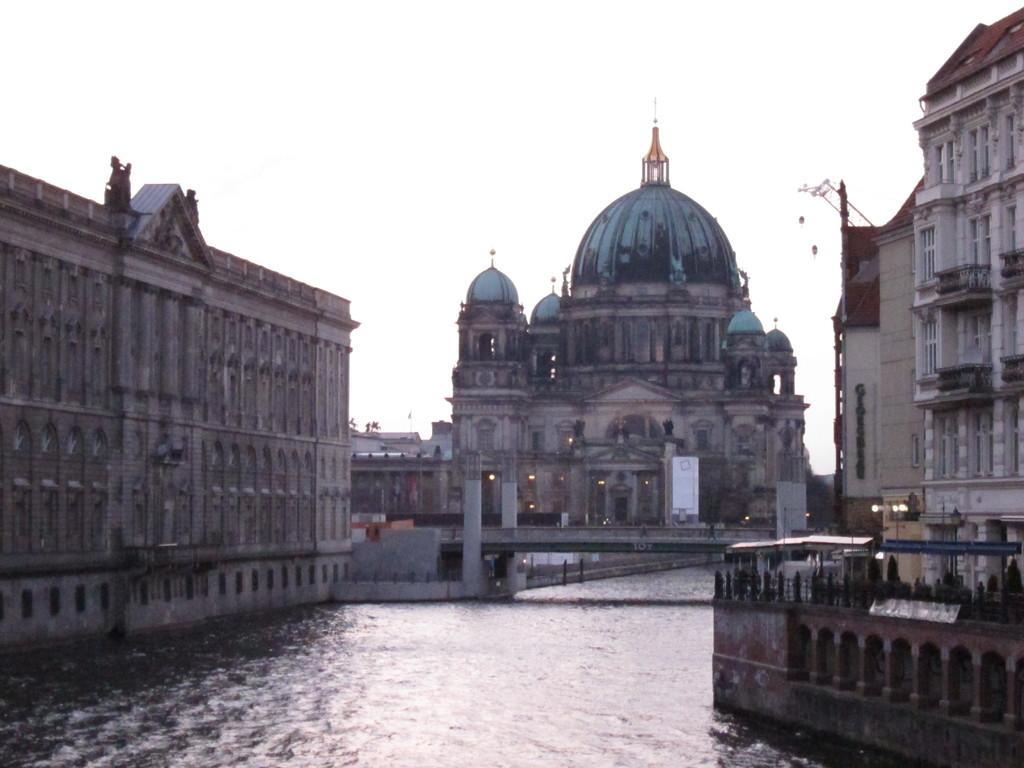Can you describe this image briefly? In this picture we can see some buildings, at the bottom there is water, we can see a bridge in the middle, in the background there is a board and some lights, we can see the sky at the top of the picture. 